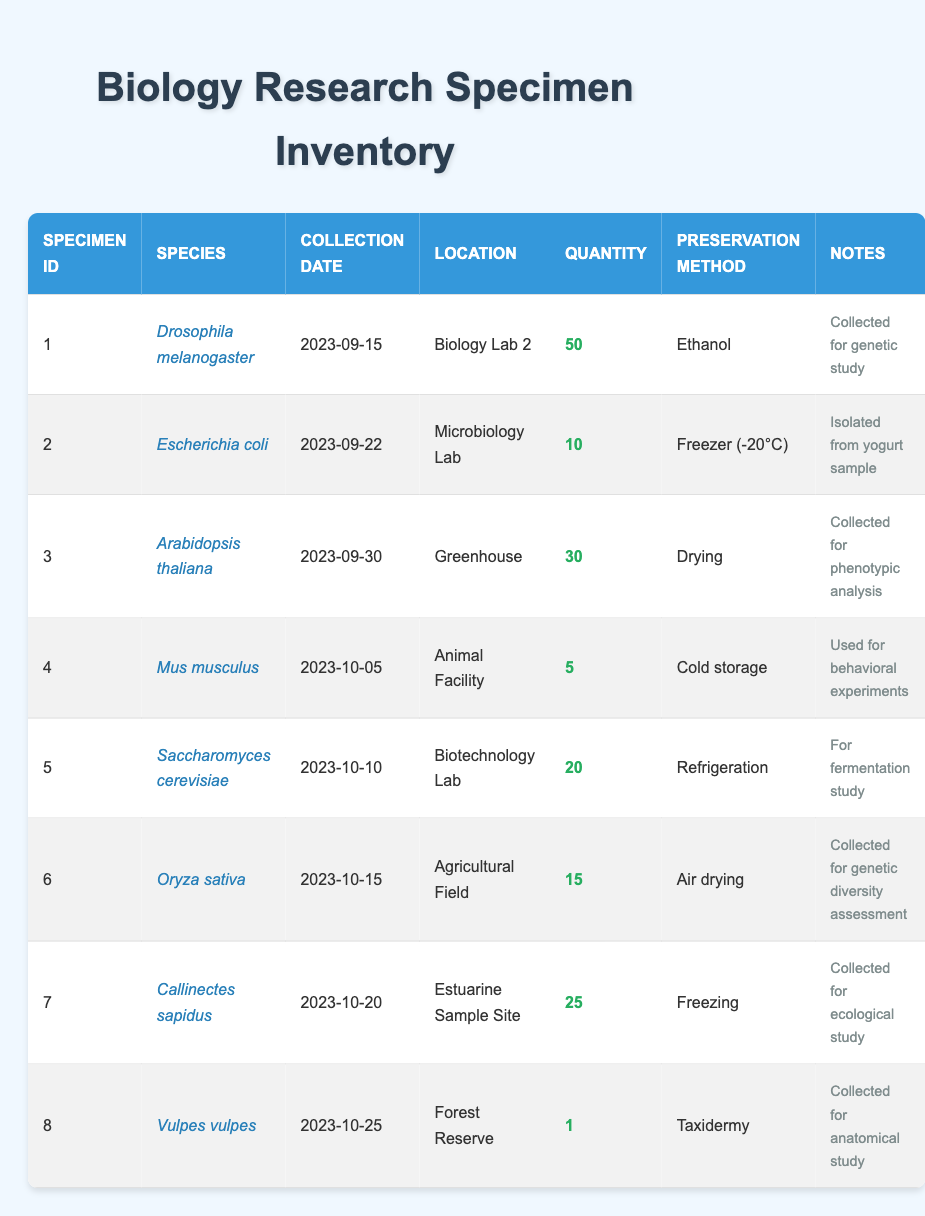What was the highest quantity of specimens collected? The specimens collected in varying quantities were Drosophila melanogaster (50), Escherichia coli (10), Arabidopsis thaliana (30), Mus musculus (5), Saccharomyces cerevisiae (20), Oryza sativa (15), Callinectes sapidus (25), and Vulpes vulpes (1). The highest number is 50 from Drosophila melanogaster.
Answer: 50 How many different species were collected in total? The table lists 8 different species: Drosophila melanogaster, Escherichia coli, Arabidopsis thaliana, Mus musculus, Saccharomyces cerevisiae, Oryza sativa, Callinectes sapidus, and Vulpes vulpes. Therefore, there are 8 distinct species in total.
Answer: 8 What is the preservation method for Mus musculus? The table indicates that Mus musculus is preserved using cold storage. This information is found directly under the preservation method column for specimen ID 4.
Answer: Cold storage Which specimen was collected on 2023-10-10? By looking at the collection date column, Saccharomyces cerevisiae corresponds to the date 2023-10-10 as it is the only record listed for that date.
Answer: Saccharomyces cerevisiae What is the total quantity of specimens collected for study related to genetic research? From the table, two specimens are related to genetic research: Drosophila melanogaster (50) for genetic study and Oryza sativa (15) for genetic diversity assessment. Adding these quantities gives 50 + 15 = 65.
Answer: 65 Were any specimens collected using taxidermy? The table indicates that Vulpes vulpes (specimen ID 8) was collected using the taxidermy method of preservation. This confirms the use of taxidermy for at least one specimen.
Answer: Yes How many more specimens of Callinectes sapidus were collected compared to Vulpes vulpes? Callinectes sapidus has a quantity of 25, while Vulpes vulpes has a quantity of 1. The difference is calculated by 25 - 1 = 24, indicating that 24 more specimens of Callinectes sapidus were collected than Vulpes vulpes.
Answer: 24 What type of study were the specimens collected on 2023-10-05 used for? The notes for Mus musculus collected on this date state that it was used for behavioral experiments. This can be cross-referenced directly in the notes column for specimen ID 4.
Answer: Behavioral experiments 